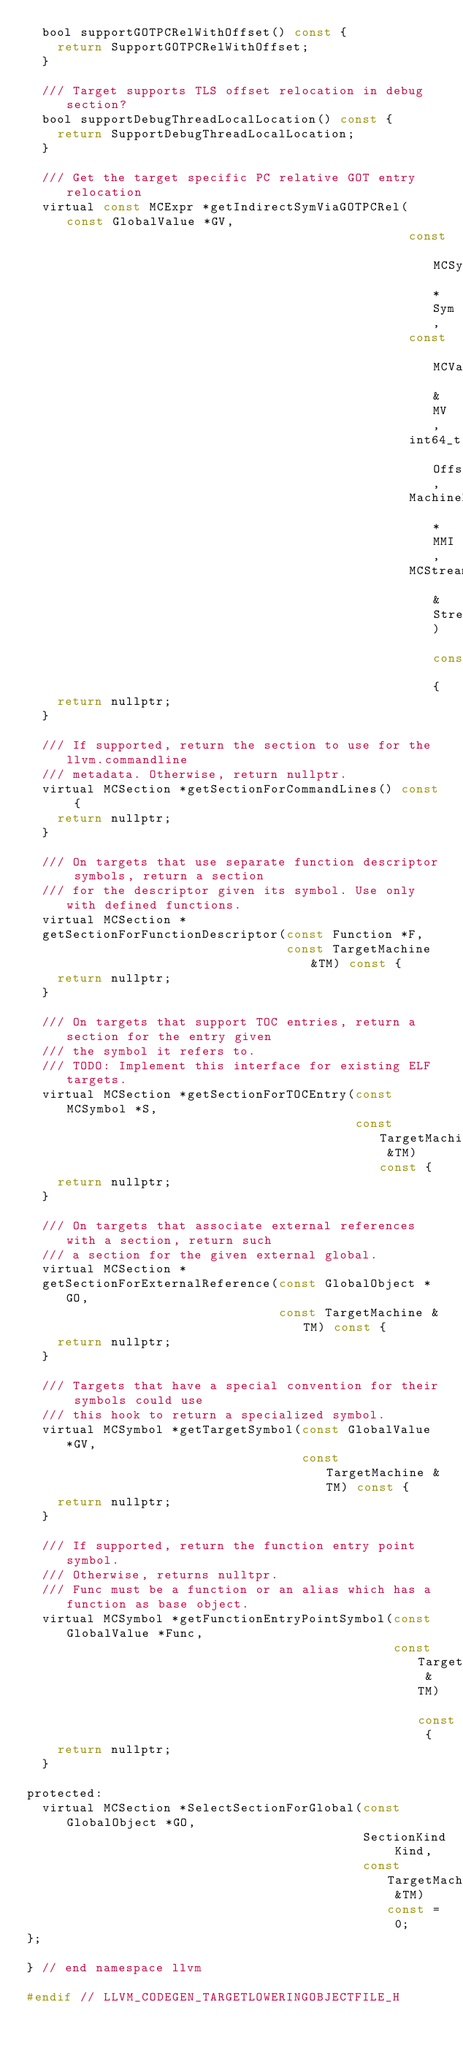<code> <loc_0><loc_0><loc_500><loc_500><_C_>  bool supportGOTPCRelWithOffset() const {
    return SupportGOTPCRelWithOffset;
  }

  /// Target supports TLS offset relocation in debug section?
  bool supportDebugThreadLocalLocation() const {
    return SupportDebugThreadLocalLocation;
  }

  /// Get the target specific PC relative GOT entry relocation
  virtual const MCExpr *getIndirectSymViaGOTPCRel(const GlobalValue *GV,
                                                  const MCSymbol *Sym,
                                                  const MCValue &MV,
                                                  int64_t Offset,
                                                  MachineModuleInfo *MMI,
                                                  MCStreamer &Streamer) const {
    return nullptr;
  }

  /// If supported, return the section to use for the llvm.commandline
  /// metadata. Otherwise, return nullptr.
  virtual MCSection *getSectionForCommandLines() const {
    return nullptr;
  }

  /// On targets that use separate function descriptor symbols, return a section
  /// for the descriptor given its symbol. Use only with defined functions.
  virtual MCSection *
  getSectionForFunctionDescriptor(const Function *F,
                                  const TargetMachine &TM) const {
    return nullptr;
  }

  /// On targets that support TOC entries, return a section for the entry given
  /// the symbol it refers to.
  /// TODO: Implement this interface for existing ELF targets.
  virtual MCSection *getSectionForTOCEntry(const MCSymbol *S,
                                           const TargetMachine &TM) const {
    return nullptr;
  }

  /// On targets that associate external references with a section, return such
  /// a section for the given external global.
  virtual MCSection *
  getSectionForExternalReference(const GlobalObject *GO,
                                 const TargetMachine &TM) const {
    return nullptr;
  }

  /// Targets that have a special convention for their symbols could use
  /// this hook to return a specialized symbol.
  virtual MCSymbol *getTargetSymbol(const GlobalValue *GV,
                                    const TargetMachine &TM) const {
    return nullptr;
  }

  /// If supported, return the function entry point symbol.
  /// Otherwise, returns nulltpr.
  /// Func must be a function or an alias which has a function as base object.
  virtual MCSymbol *getFunctionEntryPointSymbol(const GlobalValue *Func,
                                                const TargetMachine &TM) const {
    return nullptr;
  }

protected:
  virtual MCSection *SelectSectionForGlobal(const GlobalObject *GO,
                                            SectionKind Kind,
                                            const TargetMachine &TM) const = 0;
};

} // end namespace llvm

#endif // LLVM_CODEGEN_TARGETLOWERINGOBJECTFILE_H
</code> 